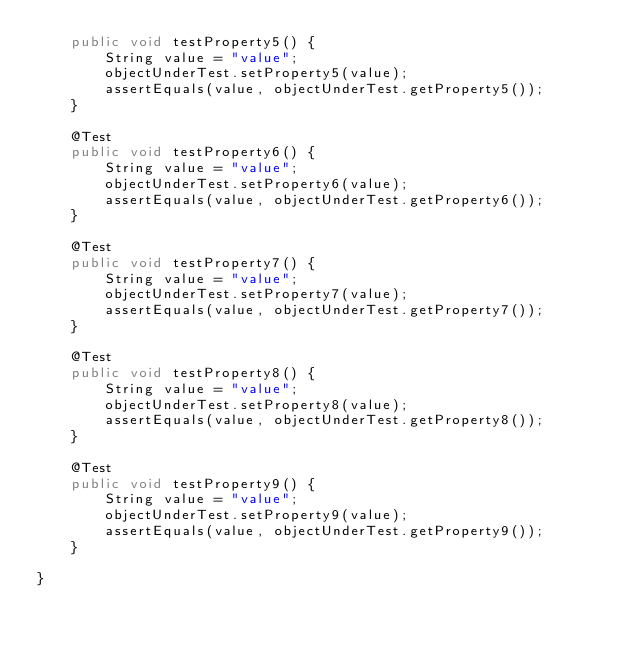Convert code to text. <code><loc_0><loc_0><loc_500><loc_500><_Java_>    public void testProperty5() {
        String value = "value";
        objectUnderTest.setProperty5(value);
        assertEquals(value, objectUnderTest.getProperty5());
    }

    @Test
    public void testProperty6() {
        String value = "value";
        objectUnderTest.setProperty6(value);
        assertEquals(value, objectUnderTest.getProperty6());
    }

    @Test
    public void testProperty7() {
        String value = "value";
        objectUnderTest.setProperty7(value);
        assertEquals(value, objectUnderTest.getProperty7());
    }

    @Test
    public void testProperty8() {
        String value = "value";
        objectUnderTest.setProperty8(value);
        assertEquals(value, objectUnderTest.getProperty8());
    }

    @Test
    public void testProperty9() {
        String value = "value";
        objectUnderTest.setProperty9(value);
        assertEquals(value, objectUnderTest.getProperty9());
    }

}</code> 